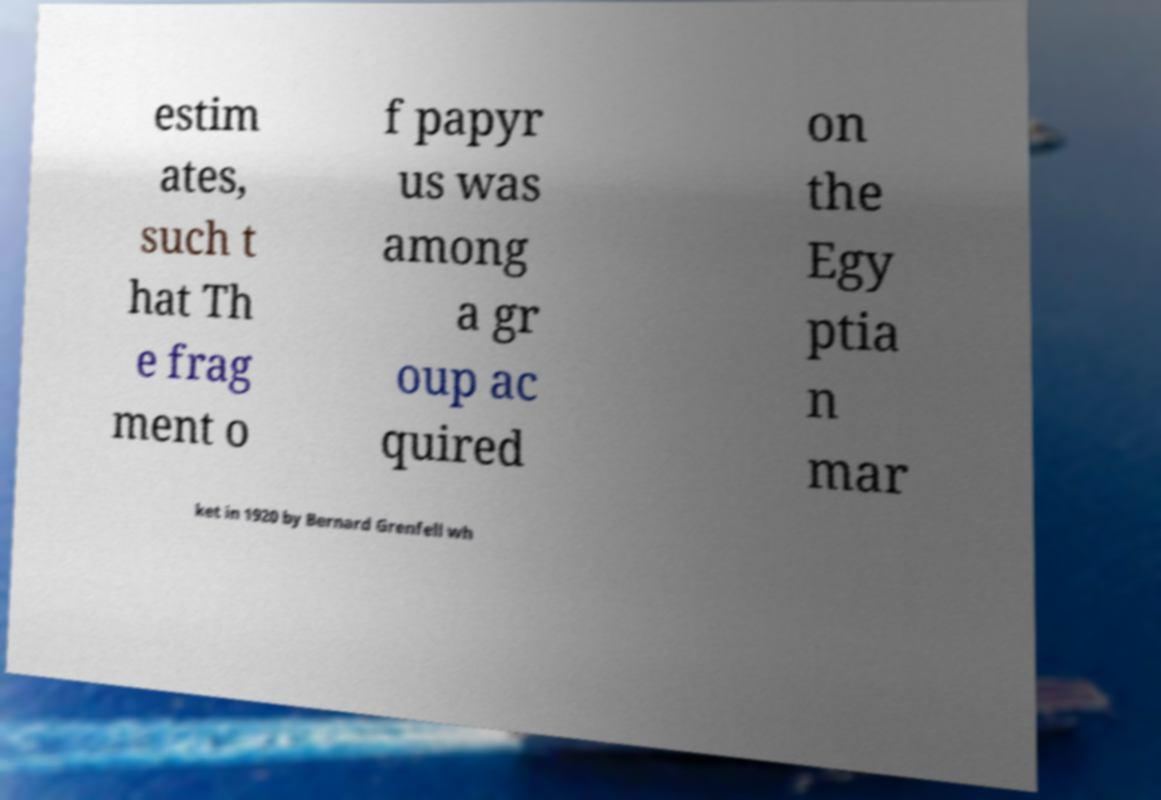I need the written content from this picture converted into text. Can you do that? estim ates, such t hat Th e frag ment o f papyr us was among a gr oup ac quired on the Egy ptia n mar ket in 1920 by Bernard Grenfell wh 